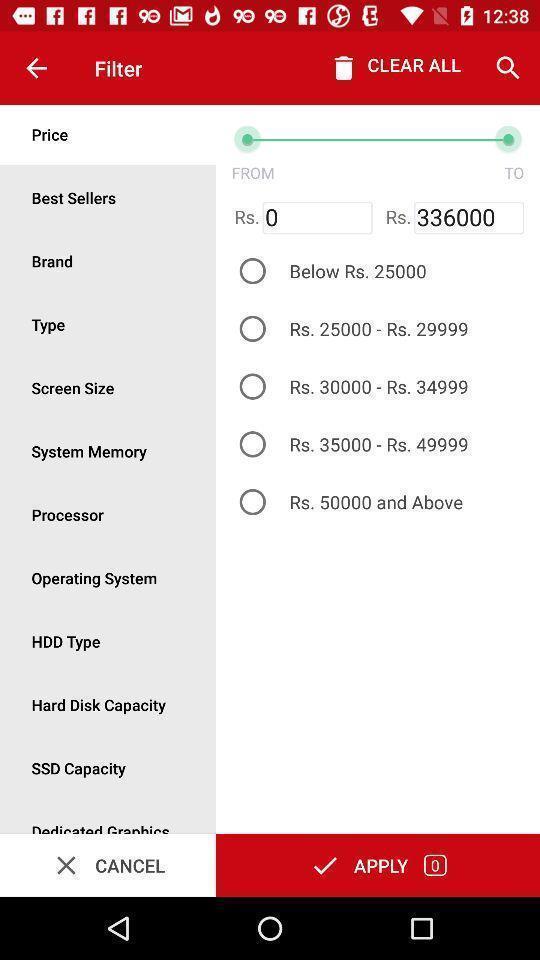Explain the elements present in this screenshot. Price and other filters displayed for a online shopping app. 